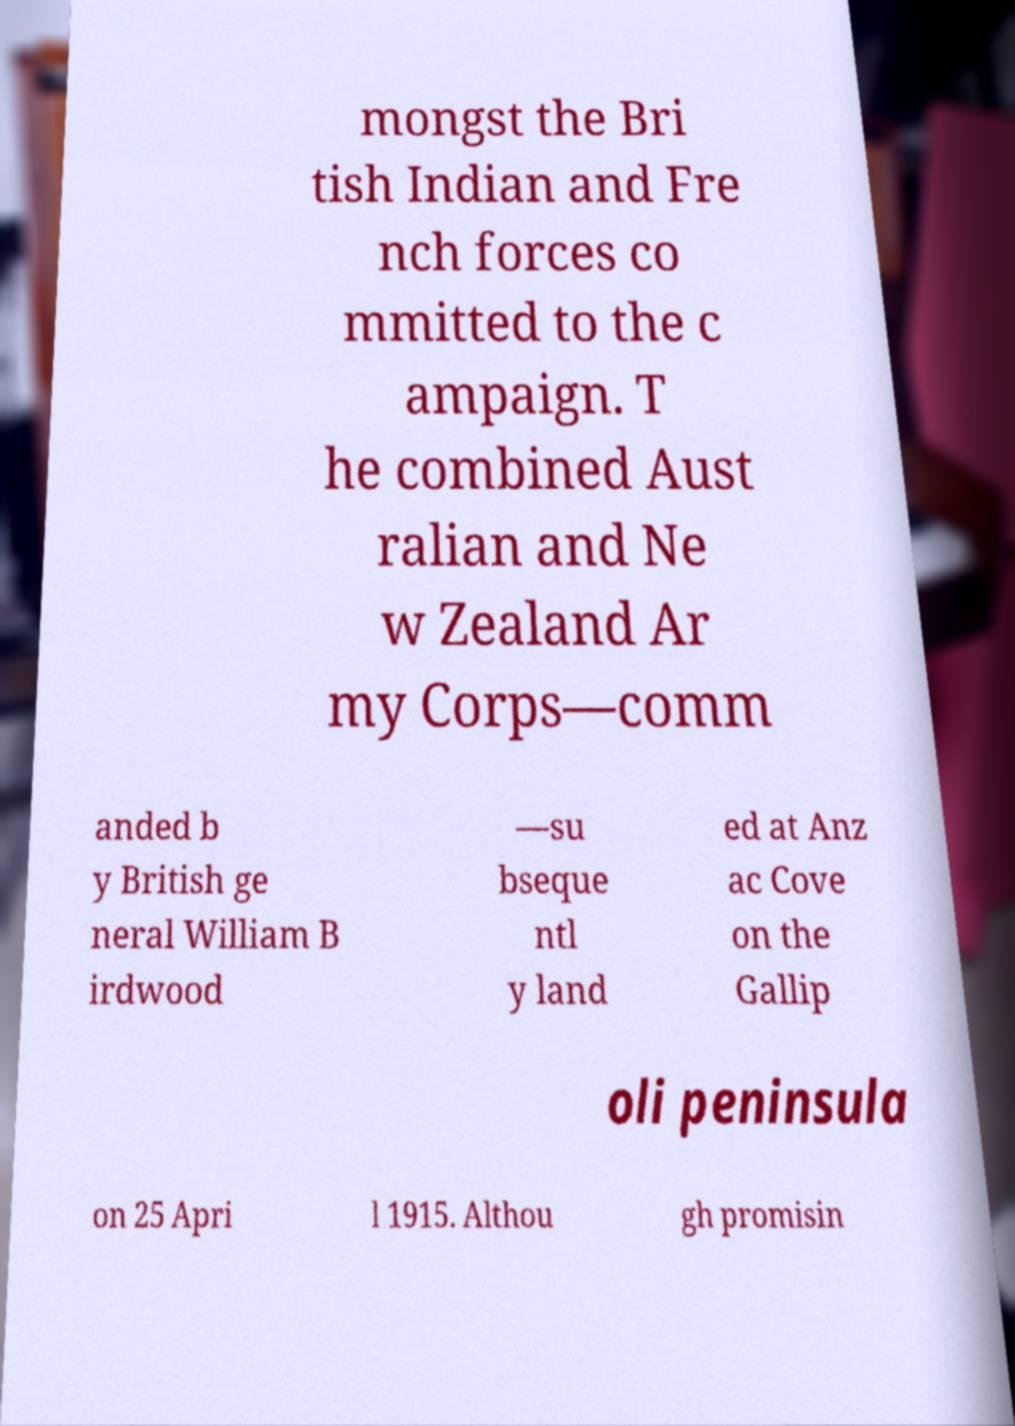Can you accurately transcribe the text from the provided image for me? mongst the Bri tish Indian and Fre nch forces co mmitted to the c ampaign. T he combined Aust ralian and Ne w Zealand Ar my Corps—comm anded b y British ge neral William B irdwood —su bseque ntl y land ed at Anz ac Cove on the Gallip oli peninsula on 25 Apri l 1915. Althou gh promisin 